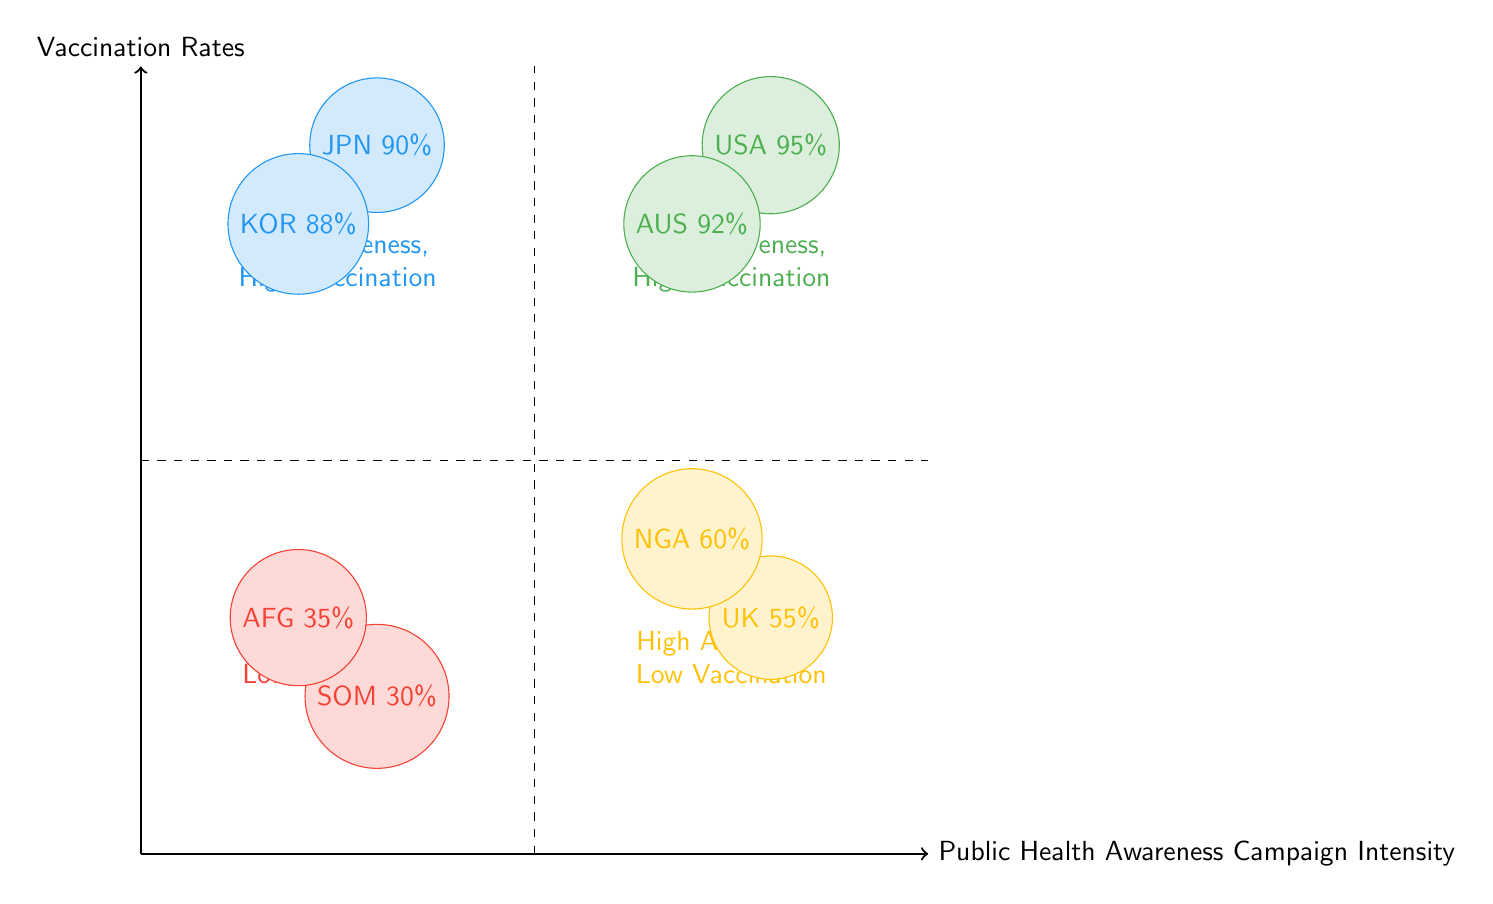What is the vaccination rate in the USA? The USA is located in the "High Awareness, High Vaccination" quadrant and has an associated vaccination rate of 95%.
Answer: 95% Which campaign is associated with the vaccination rate of 60%? The campaign showing a vaccination rate of 60% is Nigeria's Polio Eradication Campaign, found in the "High Awareness, Low Vaccination" quadrant.
Answer: Nigeria's Polio Eradication Campaign How many total examples are presented in the diagram? There are a total of 8 examples listed in the four quadrants, with each quadrant containing 2 examples.
Answer: 8 In which quadrant would you find Japan's Community Health Education? Japan's Community Health Education is located in the "Low Awareness, High Vaccination" quadrant, where it has a vaccination rate of 90%.
Answer: Low Awareness, High Vaccination What is the general trend in the "High Awareness, Low Vaccination" quadrant? The trend indicates effective public health campaigns have not reached satisfactory vaccination rates, likely due to barriers to accessibility or acceptance.
Answer: Effective campaigns, barriers present What is the difference in vaccination rates between Somalia and Afghanistan? Somalia has a vaccination rate of 30%, while Afghanistan's rate is 35%. The difference is calculated as 35% - 30%, resulting in a 5% lower rate for Somalia.
Answer: 5% Which quadrant shows campaigns that have succeeded despite low awareness? The "Low Awareness, High Vaccination" quadrant demonstrates that community-driven efforts can lead to high vaccination rates, despite low public health campaign awareness.
Answer: Low Awareness, High Vaccination What language do the nodes representing the campaigns use to describe the countries? The nodes directly indicate the country names abbreviated as three-letter codes (e.g., USA, UK, NGA) alongside their vaccination rates.
Answer: Abbreviated three-letter codes 